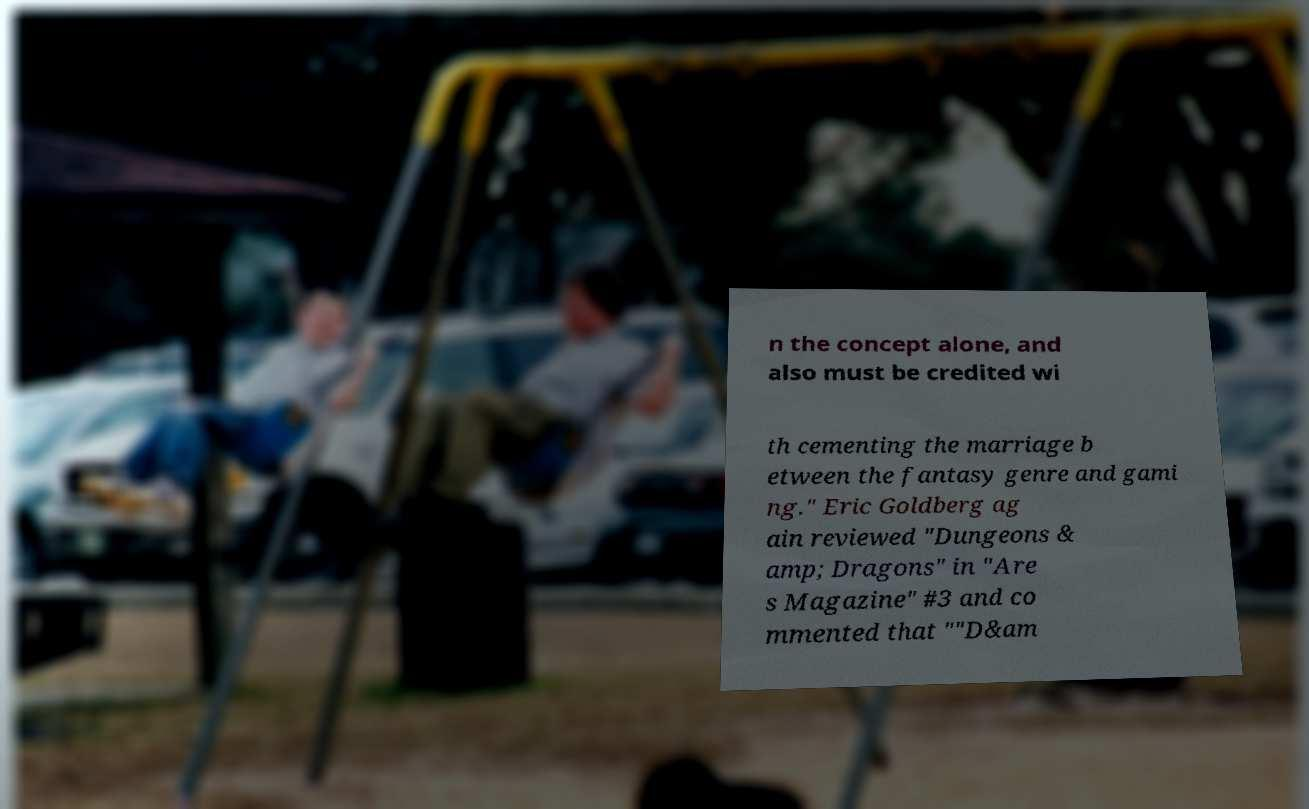There's text embedded in this image that I need extracted. Can you transcribe it verbatim? n the concept alone, and also must be credited wi th cementing the marriage b etween the fantasy genre and gami ng." Eric Goldberg ag ain reviewed "Dungeons & amp; Dragons" in "Are s Magazine" #3 and co mmented that ""D&am 